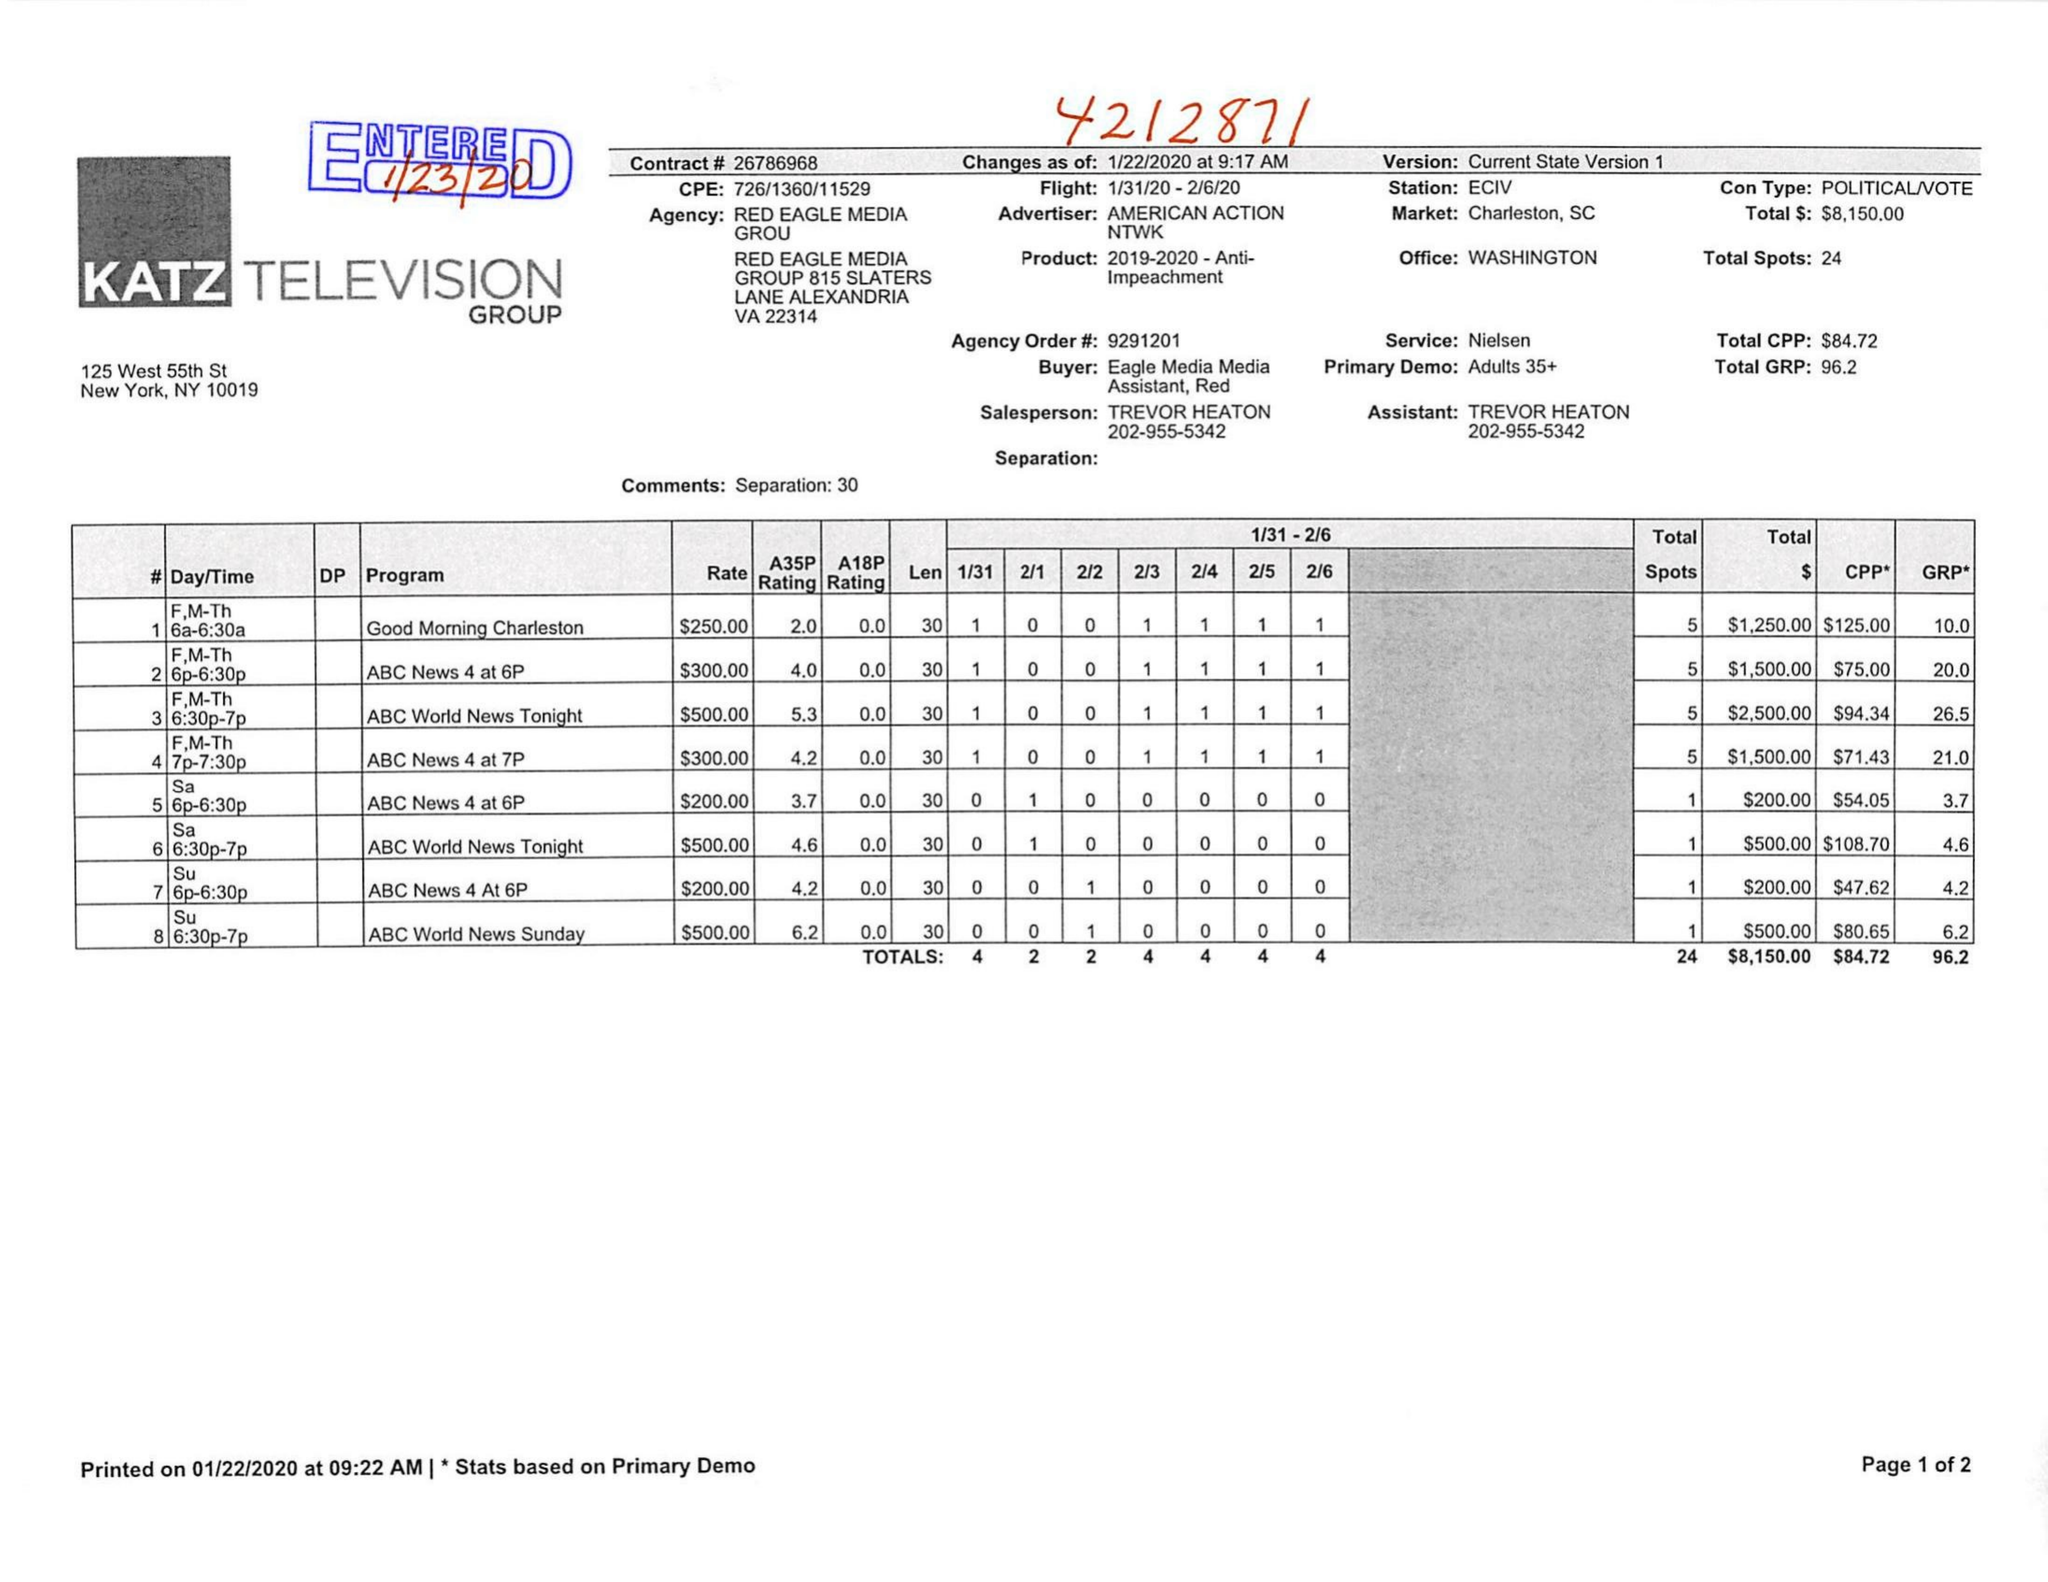What is the value for the advertiser?
Answer the question using a single word or phrase. AMERICAN ACTION NTWK 